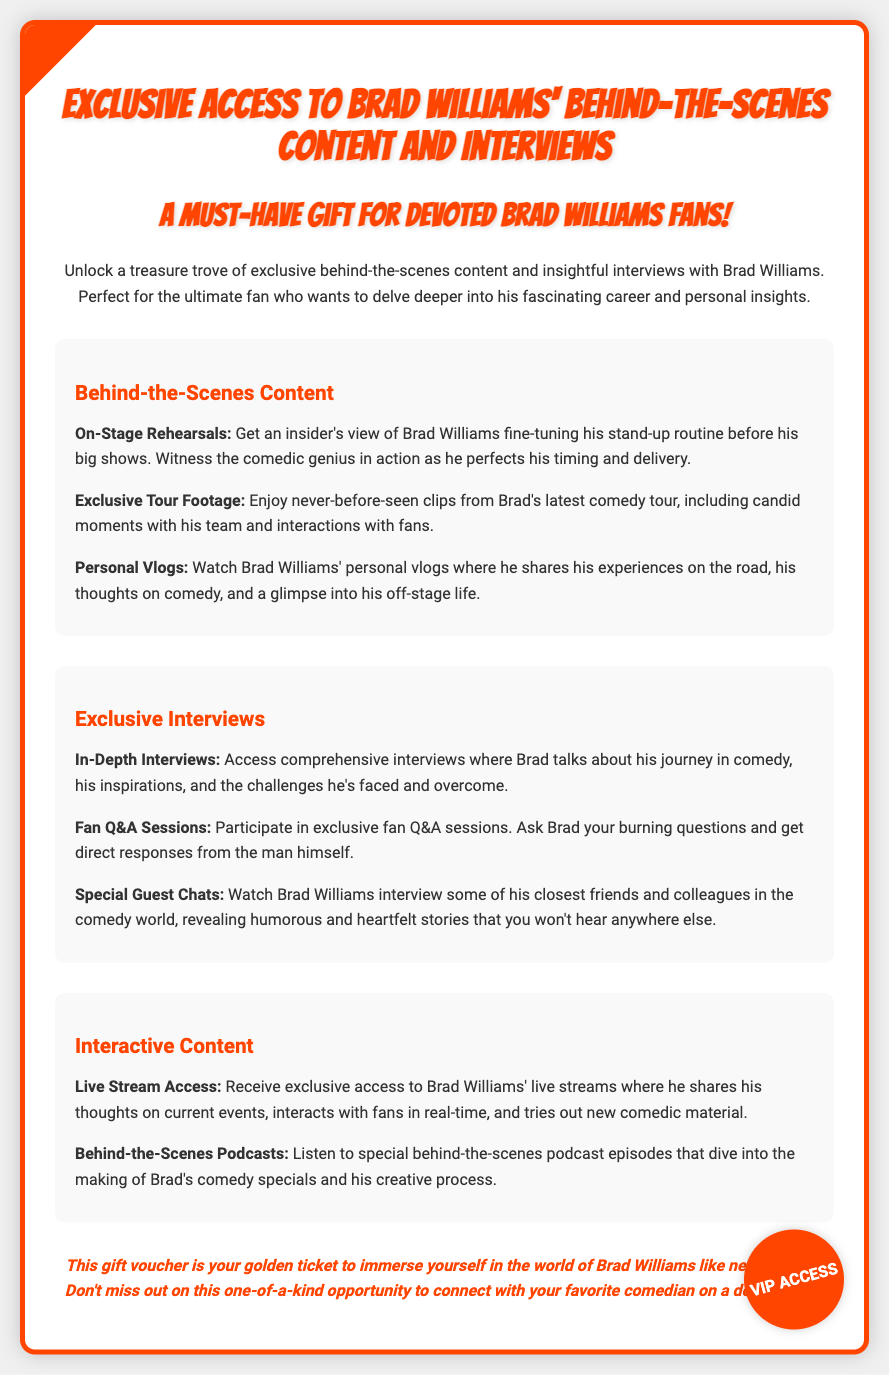What is the title of the gift voucher? The title of the gift voucher is prominently displayed at the top of the document, indicating the content it provides access to.
Answer: Exclusive Access to Brad Williams' Behind-the-Scenes Content and Interviews What type of content can fans expect from the gift voucher? The document outlines various types of content available, including behind-the-scenes and interviews specifically focusing on Brad Williams.
Answer: Behind-the-Scenes Content and Interviews What unique feature is included for fans in the document? The document highlights several exclusive features, emphasizing direct engagement with Brad through interactive content.
Answer: Fan Q&A Sessions What color is used for the title headings? The document employs a specific color scheme for the title headings that contributes to its overall design and branding.
Answer: Orange What kind of personal insights does Brad share in his vlogs? The document mentions that Brad shares specific types of insights through personal vlogs, providing a glimpse into his experiences.
Answer: Experiences on the road What is the purpose of the "VIP ACCESS" stamp? The stamp serves to emphasize the exclusivity of the content available to fans who possess this gift voucher.
Answer: Emphasizes exclusivity How can fans interact with Brad during live streams? The document describes that during live streams, there is an opportunity for real-time interaction between Brad and his fans.
Answer: Real-time interaction What is the main benefit of using this gift voucher? The primary advantage of the gift voucher is highlighted in the conclusion, showcasing its intent to connect fans more personally with Brad.
Answer: Immersion in Brad Williams' world 